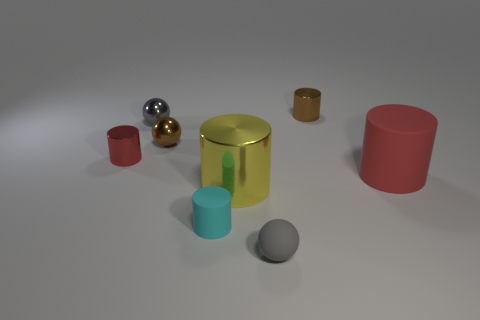Are the large red object and the large object that is in front of the red matte cylinder made of the same material?
Ensure brevity in your answer.  No. There is a cyan cylinder that is the same size as the brown metallic cylinder; what is it made of?
Ensure brevity in your answer.  Rubber. Are there any things that have the same size as the yellow shiny cylinder?
Make the answer very short. Yes. What is the shape of the cyan thing that is the same size as the gray shiny object?
Offer a terse response. Cylinder. How many other objects are there of the same color as the tiny matte sphere?
Give a very brief answer. 1. What shape is the small object that is in front of the red rubber thing and right of the yellow shiny cylinder?
Offer a very short reply. Sphere. There is a red cylinder that is on the right side of the gray ball in front of the large rubber cylinder; is there a small gray ball that is behind it?
Offer a terse response. Yes. How many other things are there of the same material as the tiny cyan cylinder?
Your answer should be very brief. 2. What number of large brown balls are there?
Your response must be concise. 0. How many objects are red shiny things or tiny gray balls that are behind the big matte thing?
Make the answer very short. 2. 